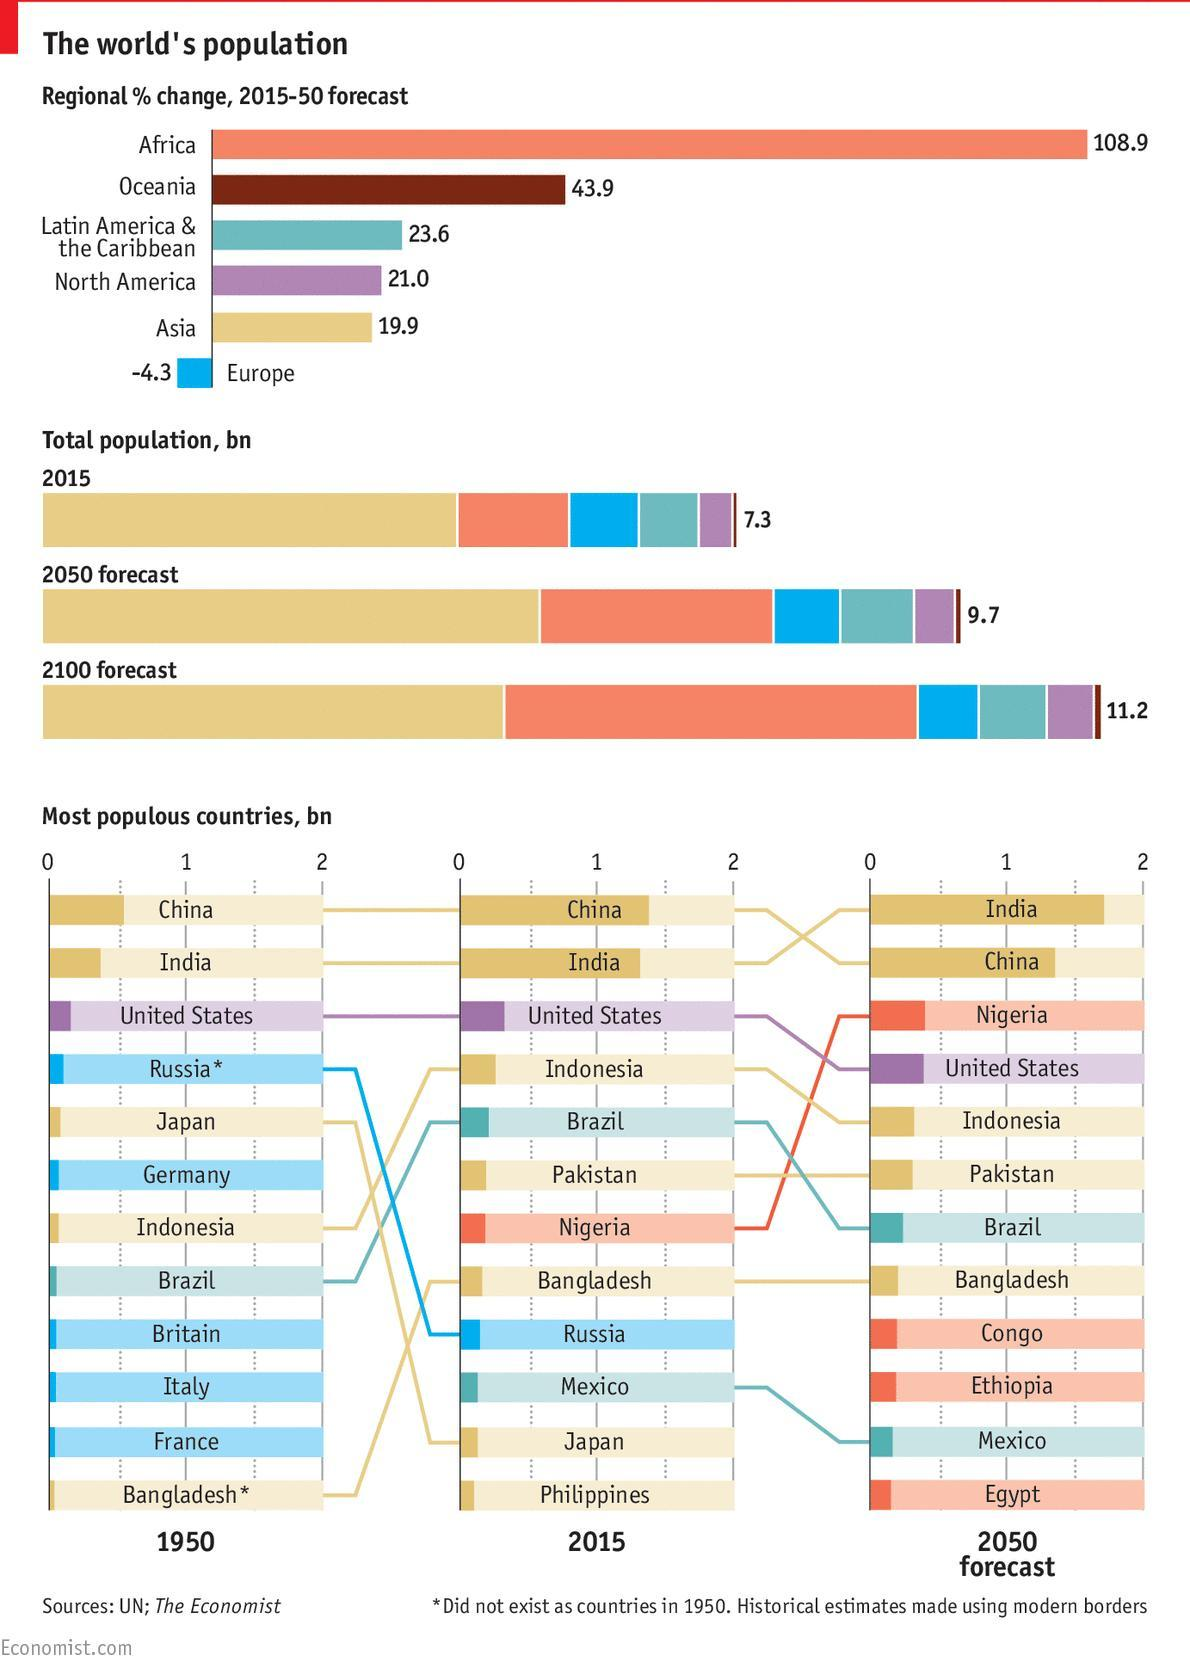Which region will have the fourth-highest population by 2050?
Answer the question with a short phrase. North America Which country is expecting a progressive increase in its population from 2015- 2050? Nigeria By 2100 forecast which region will have the highest population? Asia Which country has the highest decline in its population from 1950 to 2015? Japan Which country has the third-highest population in 2015? United States Which region has the highest population in 2015? Asia By 2050 forecast which region will have the second-highest population? Africa Which country's population growth is constant from 2015-2050? Pakistan, Bangladesh What is the most populous country by 2050? India Which region will have the third-highest population by 2050? Latin America & the Caribbean 